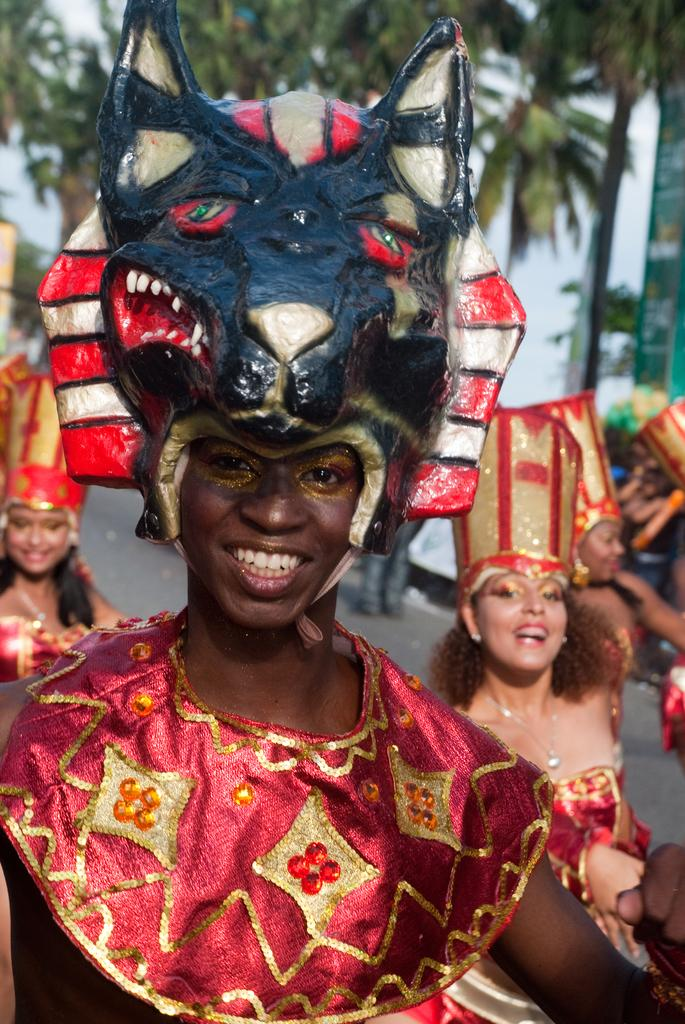How many people are in the image? There is a group of people in the image. Where are the people located in the image? The people are standing on the road. What are the people wearing in the image? The people are wearing costumes. What can be seen in the background of the image? There is a group of trees, a pole, and a board visible in the background. How many pigs are visible in the image? There are no pigs present in the image. What suggestion can be made to improve the costumes in the image? The provided facts do not include any information about the quality or appearance of the costumes, so it is not possible to make a suggestion for improvement. 